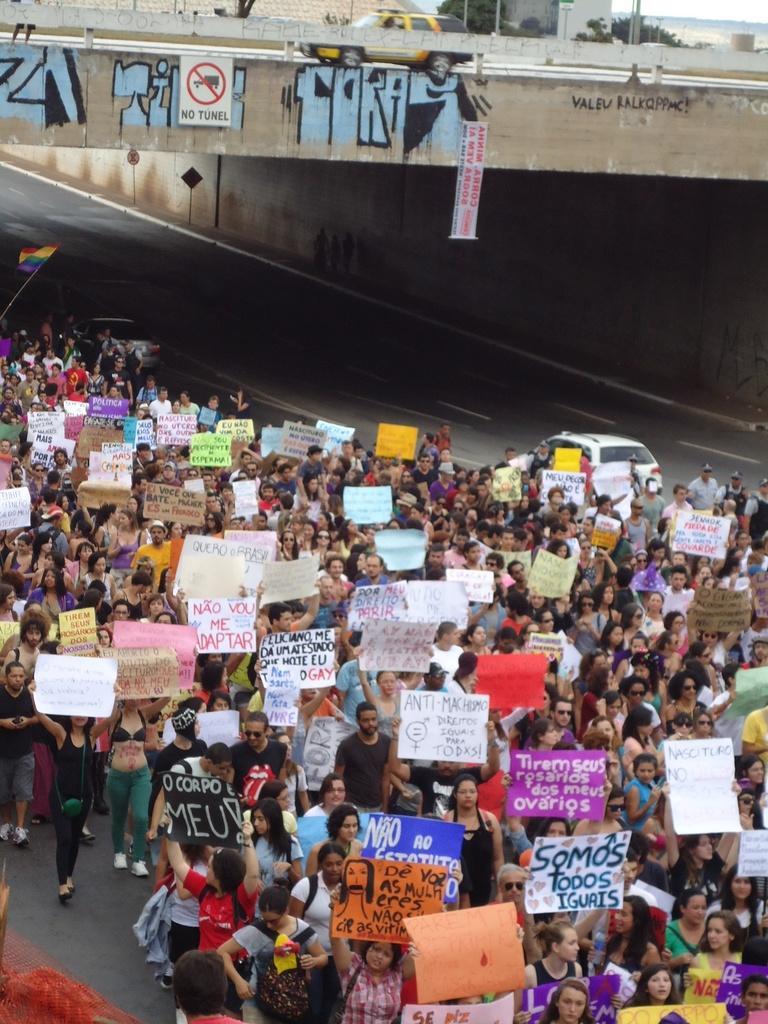Could you give a brief overview of what you see in this image? In this picture we can see a group of people holding posters with their hands, walking on the road, vehicles, bridge, some objects and in the background we can see a building, trees. 